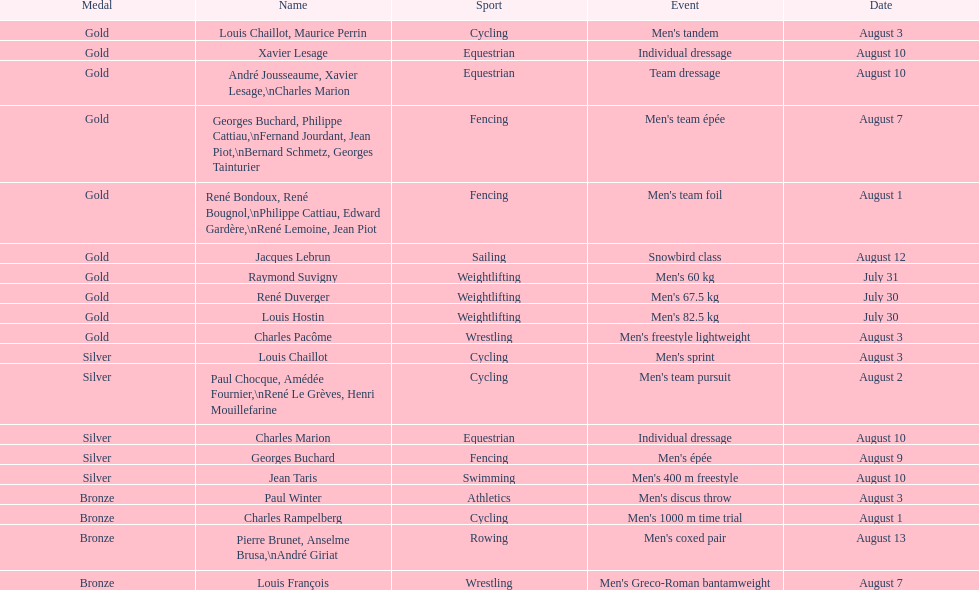How many gold medals did this country win during these olympics? 10. 